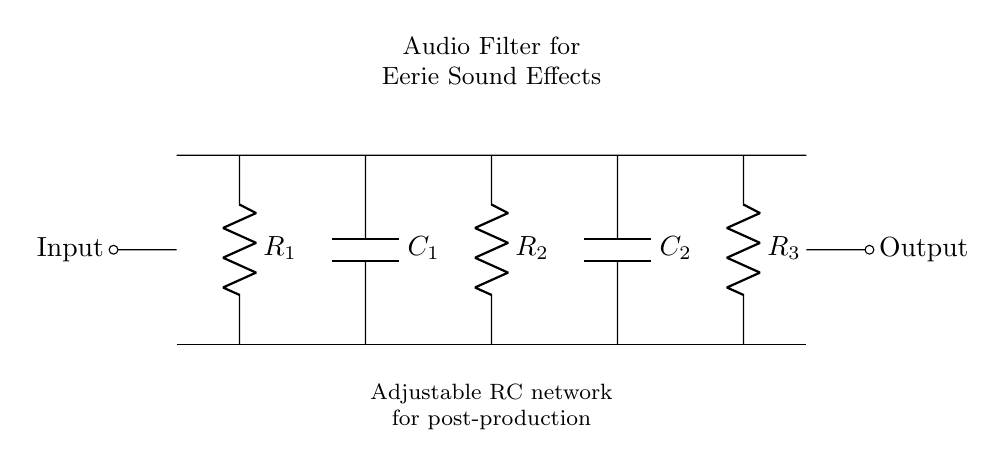What is the total number of resistors in this circuit? The circuit diagram shows three distinct resistors labeled R1, R2, and R3. Counting these components gives us a total of three resistors.
Answer: three What is the total number of capacitors in this circuit? In the diagram, there are two capacitors identified as C1 and C2. Therefore, by counting these components, we find that there are two capacitors.
Answer: two What type of circuit elements are R1 and R2? R1 and R2 are both classified as resistors since they are labeled with an R and marked with a resistance value. This classification is evident in their presentation within the circuit as components restricting current flow.
Answer: resistors Which component is first in the signal path? The input signal flows from the left, where the first component encountered is R1. This position indicates that R1 processes the input signal initially, making it the first component in the signal path.
Answer: R1 What is the configuration type of this filter circuit? The circuit diagram represents an RC low-pass filter arrangement. In this specific setup, resistors and capacitors are combined in a manner that allows low-frequency signals to pass while attenuating higher-frequency signals.
Answer: low-pass filter What is the purpose of the capacitors in this circuit? The capacitors (C1 and C2) in this RC network serve to block direct current (DC) and allow alternating current (AC) to pass, effectively shaping the frequency response of the circuit to enhance specific sound effects during post-production.
Answer: block DC, allow AC 